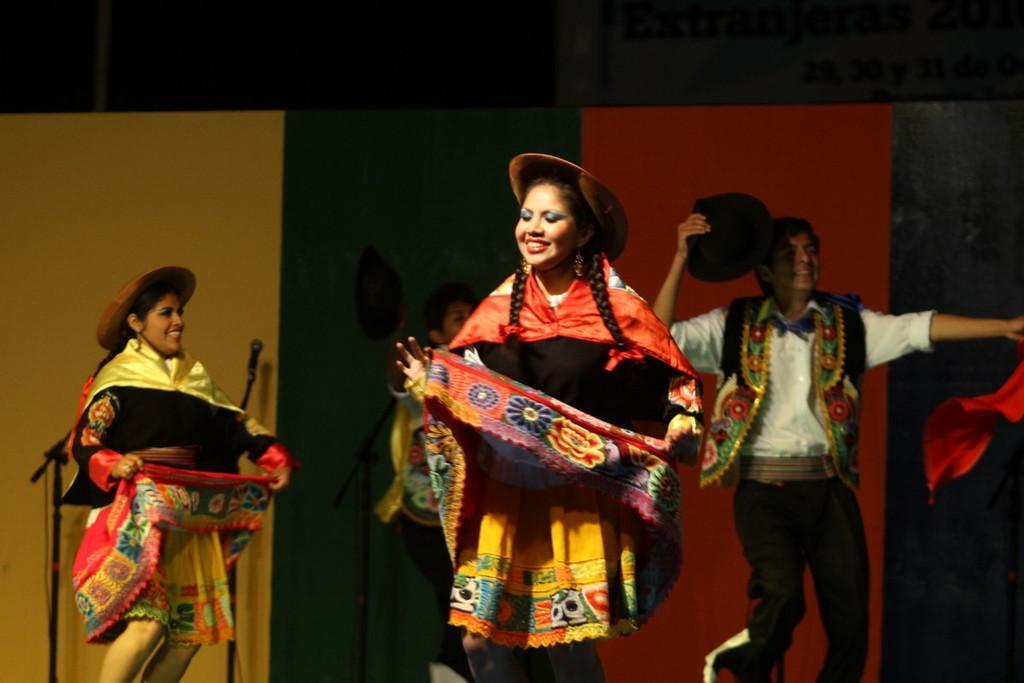Could you give a brief overview of what you see in this image? In this picture we can see people dancing. These are hats. Here we can see a mike with stand. 